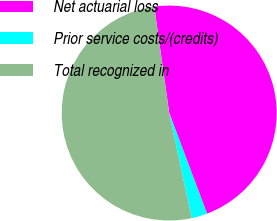Convert chart. <chart><loc_0><loc_0><loc_500><loc_500><pie_chart><fcel>Net actuarial loss<fcel>Prior service costs/(credits)<fcel>Total recognized in<nl><fcel>46.49%<fcel>2.37%<fcel>51.14%<nl></chart> 